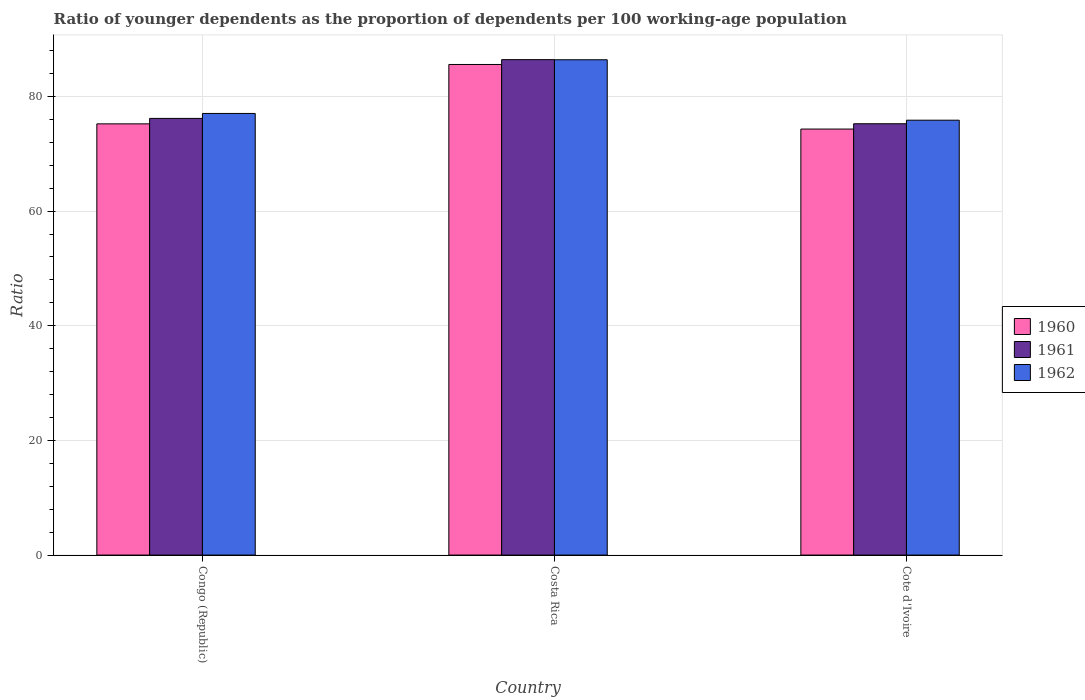How many different coloured bars are there?
Provide a short and direct response. 3. Are the number of bars per tick equal to the number of legend labels?
Offer a terse response. Yes. What is the label of the 2nd group of bars from the left?
Ensure brevity in your answer.  Costa Rica. What is the age dependency ratio(young) in 1962 in Congo (Republic)?
Provide a short and direct response. 77.04. Across all countries, what is the maximum age dependency ratio(young) in 1962?
Keep it short and to the point. 86.4. Across all countries, what is the minimum age dependency ratio(young) in 1960?
Give a very brief answer. 74.32. In which country was the age dependency ratio(young) in 1961 maximum?
Offer a terse response. Costa Rica. In which country was the age dependency ratio(young) in 1962 minimum?
Your response must be concise. Cote d'Ivoire. What is the total age dependency ratio(young) in 1961 in the graph?
Make the answer very short. 237.84. What is the difference between the age dependency ratio(young) in 1961 in Congo (Republic) and that in Cote d'Ivoire?
Offer a terse response. 0.93. What is the difference between the age dependency ratio(young) in 1960 in Congo (Republic) and the age dependency ratio(young) in 1962 in Costa Rica?
Your response must be concise. -11.18. What is the average age dependency ratio(young) in 1961 per country?
Your answer should be very brief. 79.28. What is the difference between the age dependency ratio(young) of/in 1960 and age dependency ratio(young) of/in 1961 in Costa Rica?
Provide a succinct answer. -0.84. What is the ratio of the age dependency ratio(young) in 1962 in Costa Rica to that in Cote d'Ivoire?
Offer a terse response. 1.14. Is the age dependency ratio(young) in 1960 in Congo (Republic) less than that in Costa Rica?
Give a very brief answer. Yes. Is the difference between the age dependency ratio(young) in 1960 in Costa Rica and Cote d'Ivoire greater than the difference between the age dependency ratio(young) in 1961 in Costa Rica and Cote d'Ivoire?
Give a very brief answer. Yes. What is the difference between the highest and the second highest age dependency ratio(young) in 1961?
Offer a terse response. -0.93. What is the difference between the highest and the lowest age dependency ratio(young) in 1960?
Your answer should be very brief. 11.26. In how many countries, is the age dependency ratio(young) in 1962 greater than the average age dependency ratio(young) in 1962 taken over all countries?
Your answer should be very brief. 1. Is it the case that in every country, the sum of the age dependency ratio(young) in 1960 and age dependency ratio(young) in 1961 is greater than the age dependency ratio(young) in 1962?
Ensure brevity in your answer.  Yes. How many bars are there?
Offer a terse response. 9. How many countries are there in the graph?
Provide a succinct answer. 3. Are the values on the major ticks of Y-axis written in scientific E-notation?
Your response must be concise. No. Does the graph contain grids?
Give a very brief answer. Yes. Where does the legend appear in the graph?
Keep it short and to the point. Center right. How are the legend labels stacked?
Your answer should be compact. Vertical. What is the title of the graph?
Your answer should be compact. Ratio of younger dependents as the proportion of dependents per 100 working-age population. What is the label or title of the X-axis?
Your answer should be compact. Country. What is the label or title of the Y-axis?
Give a very brief answer. Ratio. What is the Ratio of 1960 in Congo (Republic)?
Your response must be concise. 75.22. What is the Ratio in 1961 in Congo (Republic)?
Your answer should be very brief. 76.17. What is the Ratio in 1962 in Congo (Republic)?
Give a very brief answer. 77.04. What is the Ratio in 1960 in Costa Rica?
Offer a very short reply. 85.58. What is the Ratio of 1961 in Costa Rica?
Your answer should be compact. 86.42. What is the Ratio of 1962 in Costa Rica?
Your response must be concise. 86.4. What is the Ratio of 1960 in Cote d'Ivoire?
Your answer should be compact. 74.32. What is the Ratio of 1961 in Cote d'Ivoire?
Make the answer very short. 75.24. What is the Ratio of 1962 in Cote d'Ivoire?
Offer a terse response. 75.86. Across all countries, what is the maximum Ratio of 1960?
Offer a very short reply. 85.58. Across all countries, what is the maximum Ratio in 1961?
Ensure brevity in your answer.  86.42. Across all countries, what is the maximum Ratio in 1962?
Offer a very short reply. 86.4. Across all countries, what is the minimum Ratio in 1960?
Offer a very short reply. 74.32. Across all countries, what is the minimum Ratio in 1961?
Provide a succinct answer. 75.24. Across all countries, what is the minimum Ratio in 1962?
Give a very brief answer. 75.86. What is the total Ratio of 1960 in the graph?
Provide a short and direct response. 235.12. What is the total Ratio of 1961 in the graph?
Provide a short and direct response. 237.84. What is the total Ratio of 1962 in the graph?
Keep it short and to the point. 239.31. What is the difference between the Ratio of 1960 in Congo (Republic) and that in Costa Rica?
Ensure brevity in your answer.  -10.36. What is the difference between the Ratio in 1961 in Congo (Republic) and that in Costa Rica?
Offer a very short reply. -10.25. What is the difference between the Ratio of 1962 in Congo (Republic) and that in Costa Rica?
Offer a terse response. -9.37. What is the difference between the Ratio of 1960 in Congo (Republic) and that in Cote d'Ivoire?
Provide a short and direct response. 0.91. What is the difference between the Ratio of 1961 in Congo (Republic) and that in Cote d'Ivoire?
Provide a succinct answer. 0.93. What is the difference between the Ratio of 1962 in Congo (Republic) and that in Cote d'Ivoire?
Offer a very short reply. 1.18. What is the difference between the Ratio in 1960 in Costa Rica and that in Cote d'Ivoire?
Ensure brevity in your answer.  11.26. What is the difference between the Ratio of 1961 in Costa Rica and that in Cote d'Ivoire?
Offer a very short reply. 11.18. What is the difference between the Ratio of 1962 in Costa Rica and that in Cote d'Ivoire?
Offer a terse response. 10.54. What is the difference between the Ratio in 1960 in Congo (Republic) and the Ratio in 1961 in Costa Rica?
Your answer should be very brief. -11.2. What is the difference between the Ratio of 1960 in Congo (Republic) and the Ratio of 1962 in Costa Rica?
Offer a very short reply. -11.18. What is the difference between the Ratio of 1961 in Congo (Republic) and the Ratio of 1962 in Costa Rica?
Keep it short and to the point. -10.23. What is the difference between the Ratio in 1960 in Congo (Republic) and the Ratio in 1961 in Cote d'Ivoire?
Provide a short and direct response. -0.02. What is the difference between the Ratio in 1960 in Congo (Republic) and the Ratio in 1962 in Cote d'Ivoire?
Offer a terse response. -0.64. What is the difference between the Ratio of 1961 in Congo (Republic) and the Ratio of 1962 in Cote d'Ivoire?
Make the answer very short. 0.31. What is the difference between the Ratio in 1960 in Costa Rica and the Ratio in 1961 in Cote d'Ivoire?
Provide a succinct answer. 10.34. What is the difference between the Ratio in 1960 in Costa Rica and the Ratio in 1962 in Cote d'Ivoire?
Make the answer very short. 9.72. What is the difference between the Ratio in 1961 in Costa Rica and the Ratio in 1962 in Cote d'Ivoire?
Provide a short and direct response. 10.56. What is the average Ratio of 1960 per country?
Your response must be concise. 78.37. What is the average Ratio in 1961 per country?
Your answer should be compact. 79.28. What is the average Ratio in 1962 per country?
Keep it short and to the point. 79.77. What is the difference between the Ratio of 1960 and Ratio of 1961 in Congo (Republic)?
Your answer should be compact. -0.95. What is the difference between the Ratio of 1960 and Ratio of 1962 in Congo (Republic)?
Your answer should be very brief. -1.82. What is the difference between the Ratio of 1961 and Ratio of 1962 in Congo (Republic)?
Your response must be concise. -0.86. What is the difference between the Ratio in 1960 and Ratio in 1961 in Costa Rica?
Ensure brevity in your answer.  -0.84. What is the difference between the Ratio in 1960 and Ratio in 1962 in Costa Rica?
Offer a terse response. -0.82. What is the difference between the Ratio in 1961 and Ratio in 1962 in Costa Rica?
Offer a very short reply. 0.02. What is the difference between the Ratio in 1960 and Ratio in 1961 in Cote d'Ivoire?
Provide a short and direct response. -0.93. What is the difference between the Ratio in 1960 and Ratio in 1962 in Cote d'Ivoire?
Offer a terse response. -1.55. What is the difference between the Ratio of 1961 and Ratio of 1962 in Cote d'Ivoire?
Ensure brevity in your answer.  -0.62. What is the ratio of the Ratio of 1960 in Congo (Republic) to that in Costa Rica?
Offer a terse response. 0.88. What is the ratio of the Ratio of 1961 in Congo (Republic) to that in Costa Rica?
Provide a short and direct response. 0.88. What is the ratio of the Ratio of 1962 in Congo (Republic) to that in Costa Rica?
Your answer should be compact. 0.89. What is the ratio of the Ratio of 1960 in Congo (Republic) to that in Cote d'Ivoire?
Offer a terse response. 1.01. What is the ratio of the Ratio in 1961 in Congo (Republic) to that in Cote d'Ivoire?
Your answer should be compact. 1.01. What is the ratio of the Ratio in 1962 in Congo (Republic) to that in Cote d'Ivoire?
Your response must be concise. 1.02. What is the ratio of the Ratio of 1960 in Costa Rica to that in Cote d'Ivoire?
Your answer should be compact. 1.15. What is the ratio of the Ratio in 1961 in Costa Rica to that in Cote d'Ivoire?
Make the answer very short. 1.15. What is the ratio of the Ratio in 1962 in Costa Rica to that in Cote d'Ivoire?
Your answer should be compact. 1.14. What is the difference between the highest and the second highest Ratio in 1960?
Your response must be concise. 10.36. What is the difference between the highest and the second highest Ratio in 1961?
Your response must be concise. 10.25. What is the difference between the highest and the second highest Ratio of 1962?
Make the answer very short. 9.37. What is the difference between the highest and the lowest Ratio of 1960?
Your response must be concise. 11.26. What is the difference between the highest and the lowest Ratio in 1961?
Provide a succinct answer. 11.18. What is the difference between the highest and the lowest Ratio in 1962?
Your response must be concise. 10.54. 